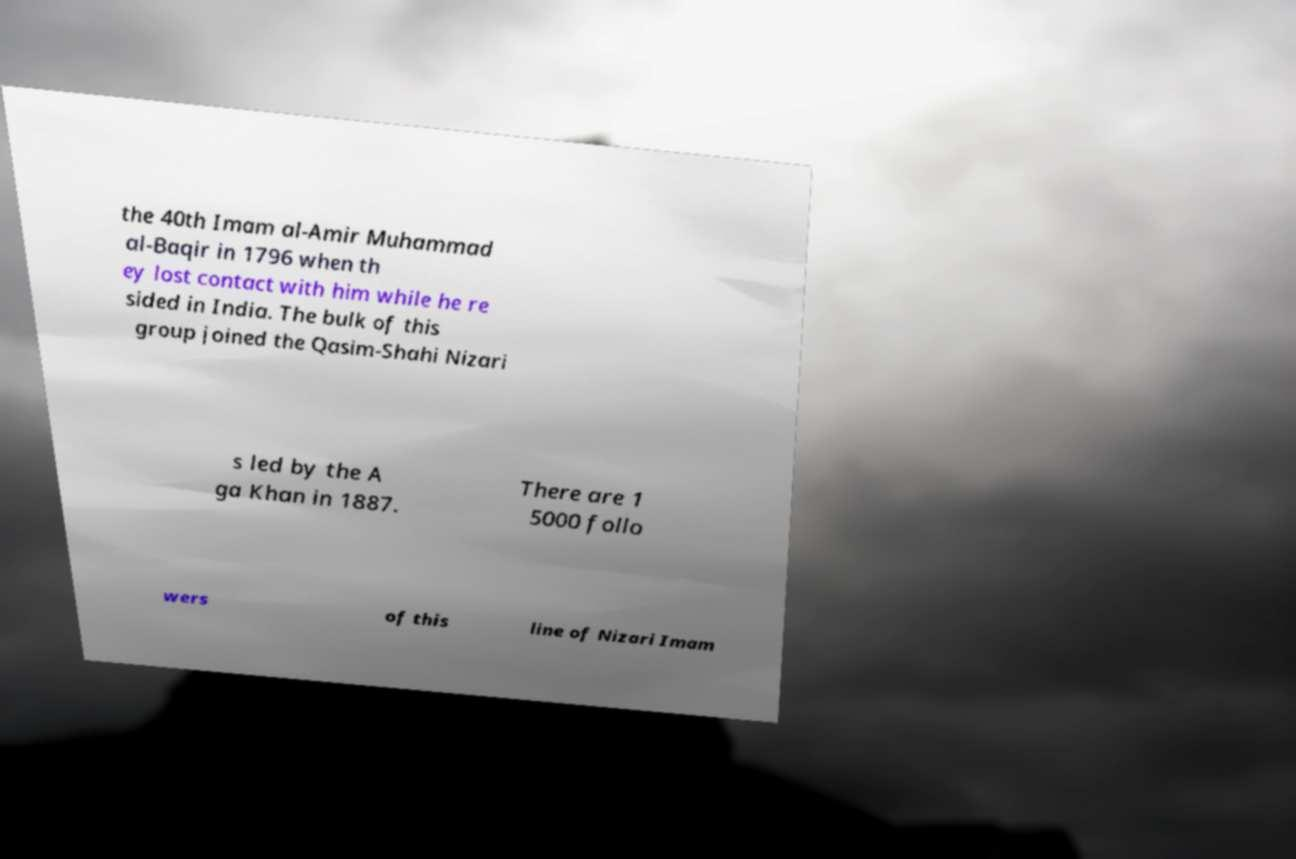Can you read and provide the text displayed in the image?This photo seems to have some interesting text. Can you extract and type it out for me? the 40th Imam al-Amir Muhammad al-Baqir in 1796 when th ey lost contact with him while he re sided in India. The bulk of this group joined the Qasim-Shahi Nizari s led by the A ga Khan in 1887. There are 1 5000 follo wers of this line of Nizari Imam 